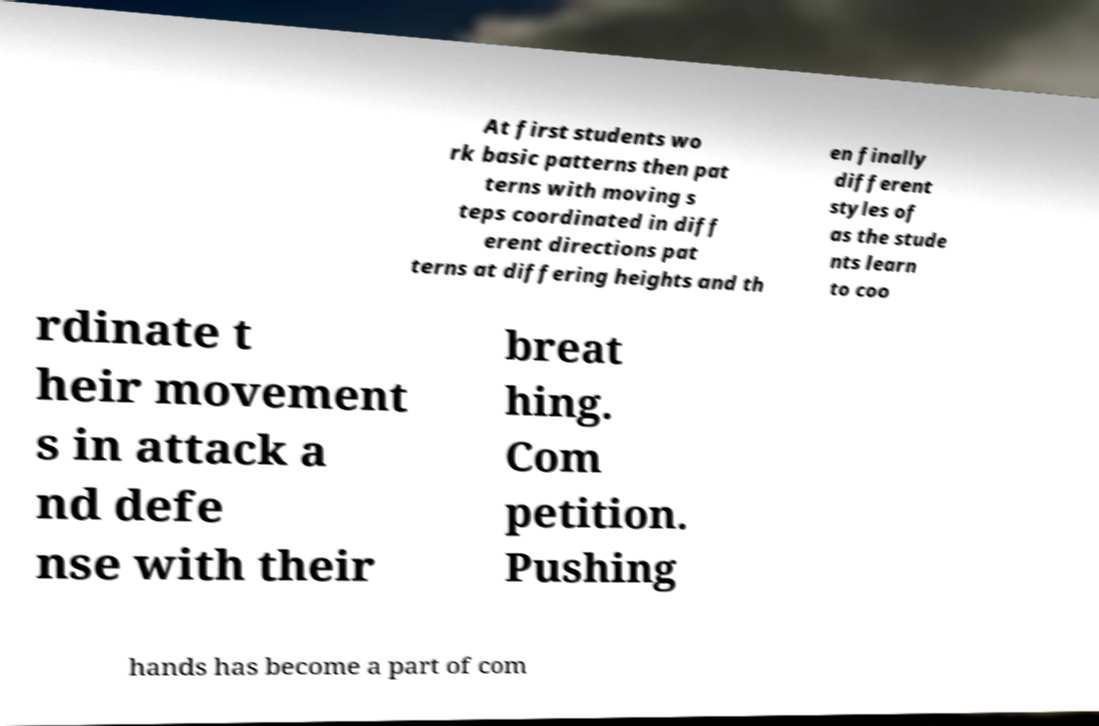Could you extract and type out the text from this image? At first students wo rk basic patterns then pat terns with moving s teps coordinated in diff erent directions pat terns at differing heights and th en finally different styles of as the stude nts learn to coo rdinate t heir movement s in attack a nd defe nse with their breat hing. Com petition. Pushing hands has become a part of com 